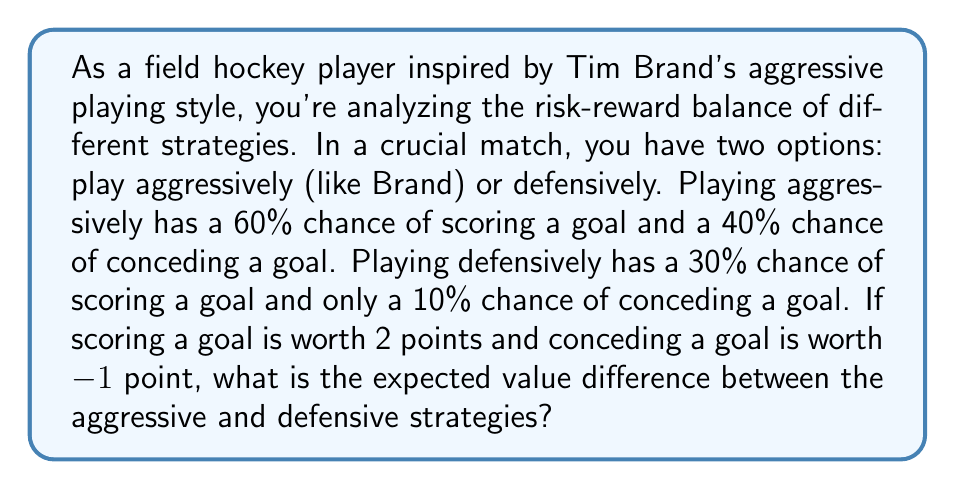Can you answer this question? Let's approach this step-by-step:

1) First, let's calculate the expected value of the aggressive strategy:
   
   $EV_{aggressive} = (0.60 \times 2) + (0.40 \times -1)$
   $= 1.20 - 0.40 = 0.80$

2) Now, let's calculate the expected value of the defensive strategy:
   
   $EV_{defensive} = (0.30 \times 2) + (0.10 \times -1)$
   $= 0.60 - 0.10 = 0.50$

3) To find the difference, we subtract the defensive expected value from the aggressive expected value:

   $Difference = EV_{aggressive} - EV_{defensive}$
   $= 0.80 - 0.50 = 0.30$

This means that the aggressive strategy has an expected value that is 0.30 points higher than the defensive strategy.

To visualize this, we can use a decision tree:

[asy]
import geometry;

size(200,150);

pair A = (0,0);
pair B1 = (100,50);
pair B2 = (100,-50);
pair C1 = (200,75);
pair C2 = (200,25);
pair C3 = (200,-25);
pair C4 = (200,-75);

draw(A--B1--C1);
draw(A--B1--C2);
draw(A--B2--C3);
draw(A--B2--C4);

label("Aggressive", (50,25), E);
label("Defensive", (50,-25), E);
label("Score (0.60)", (150,62.5), E);
label("Concede (0.40)", (150,37.5), E);
label("Score (0.30)", (150,-37.5), E);
label("Concede (0.10)", (150,-62.5), E);

dot(A);
dot(B1);
dot(B2);
dot(C1);
dot(C2);
dot(C3);
dot(C4);
[/asy]

This decision tree illustrates the probabilities and outcomes for each strategy, helping visualize why the aggressive strategy has a higher expected value.
Answer: The expected value difference between the aggressive and defensive strategies is 0.30 points in favor of the aggressive strategy. 